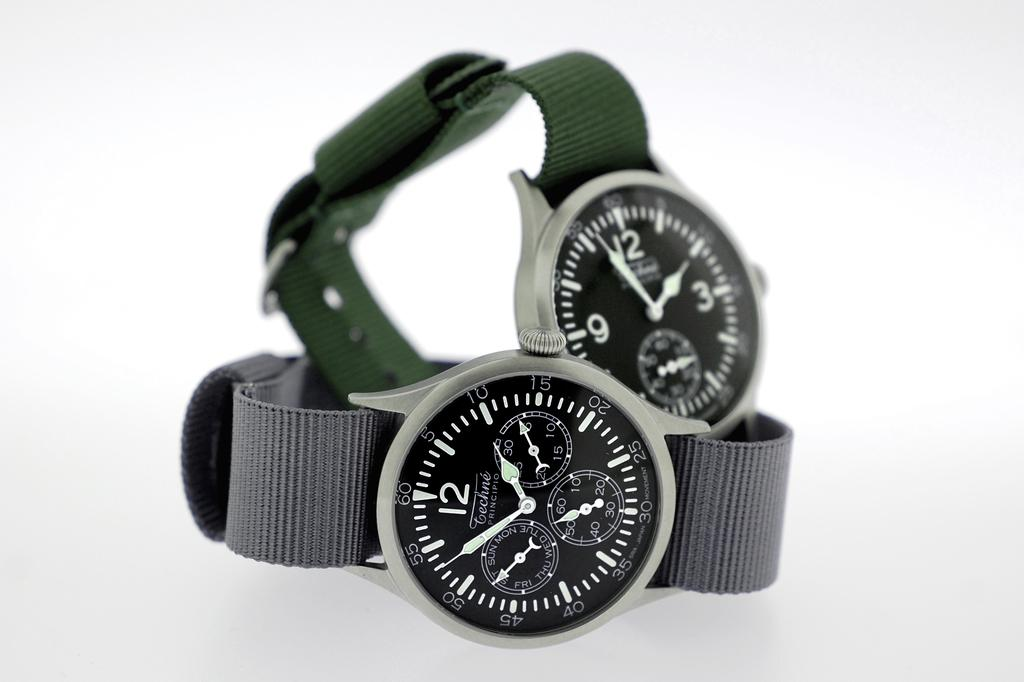<image>
Render a clear and concise summary of the photo. A black watch with the word principio on it. 